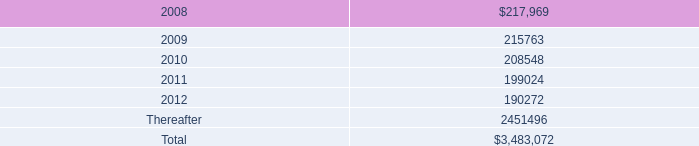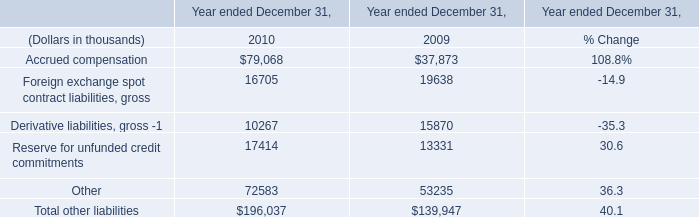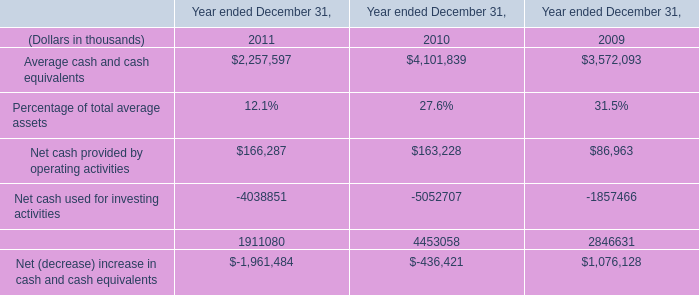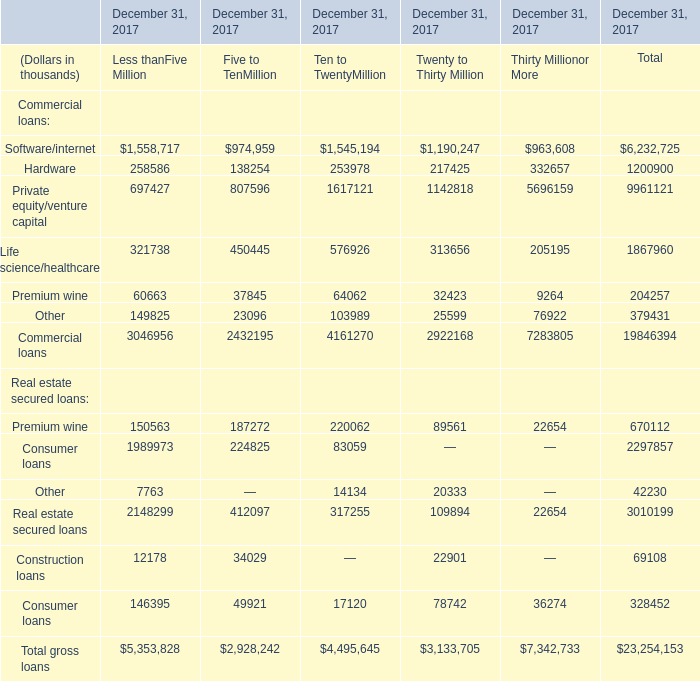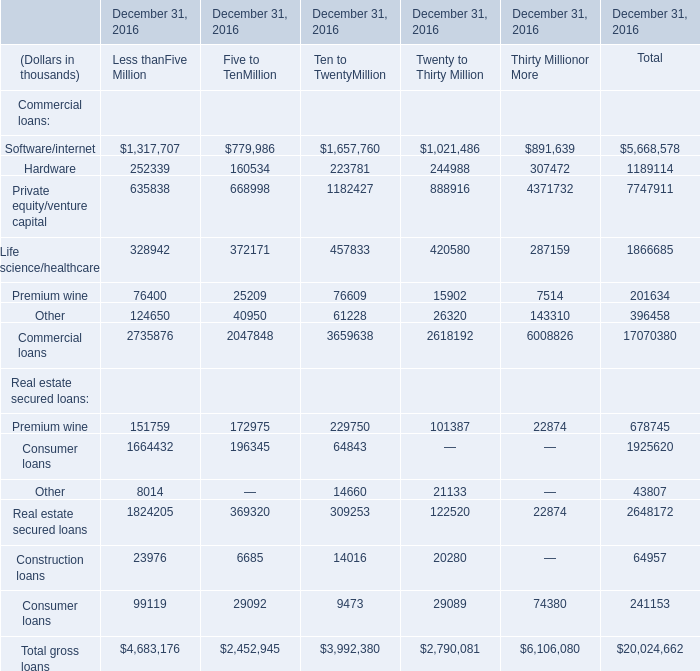what is the percentage change in aggregate rent expense from 2005 to 2006? 
Computations: ((237.0 - 168.7) / 168.7)
Answer: 0.40486. 